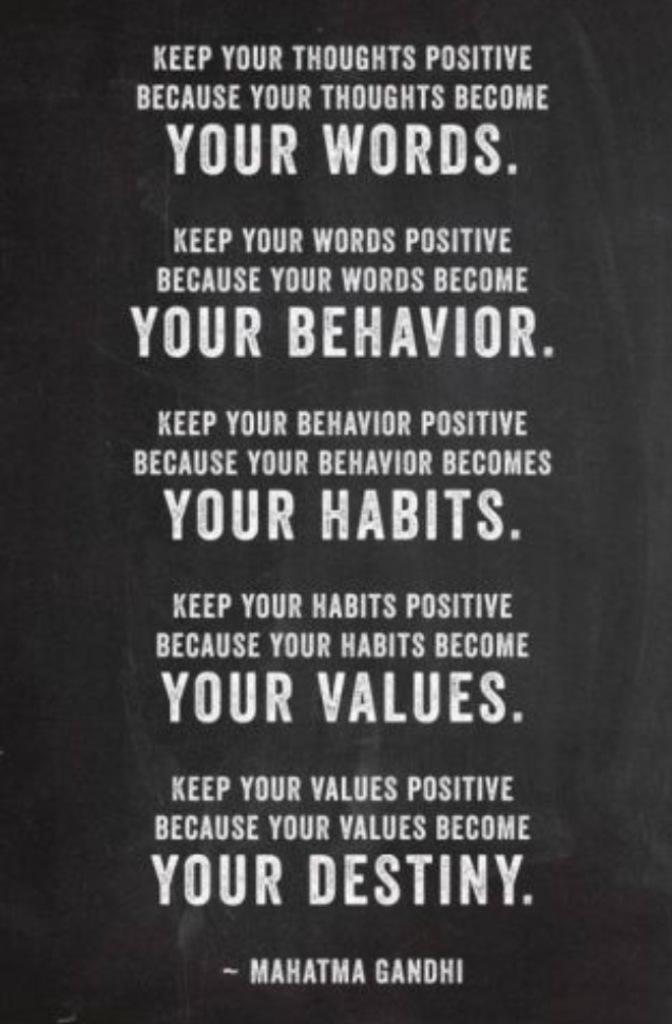Provide a one-sentence caption for the provided image. A motivational quote from Mahatma Gandhi about being positive. 